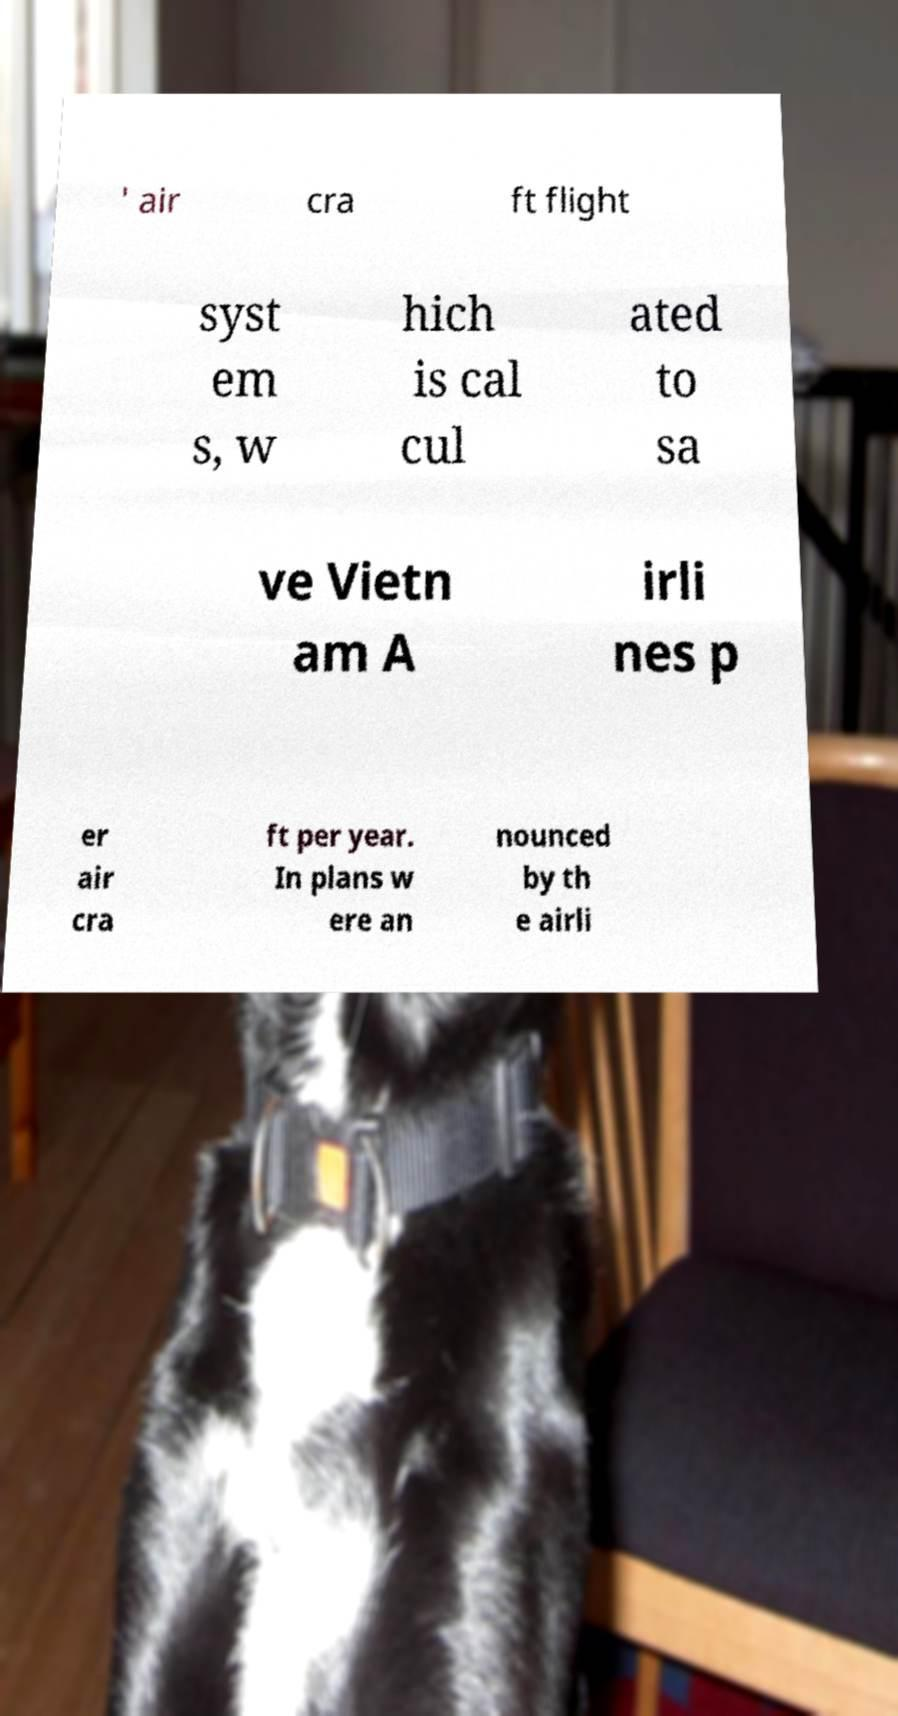For documentation purposes, I need the text within this image transcribed. Could you provide that? ' air cra ft flight syst em s, w hich is cal cul ated to sa ve Vietn am A irli nes p er air cra ft per year. In plans w ere an nounced by th e airli 